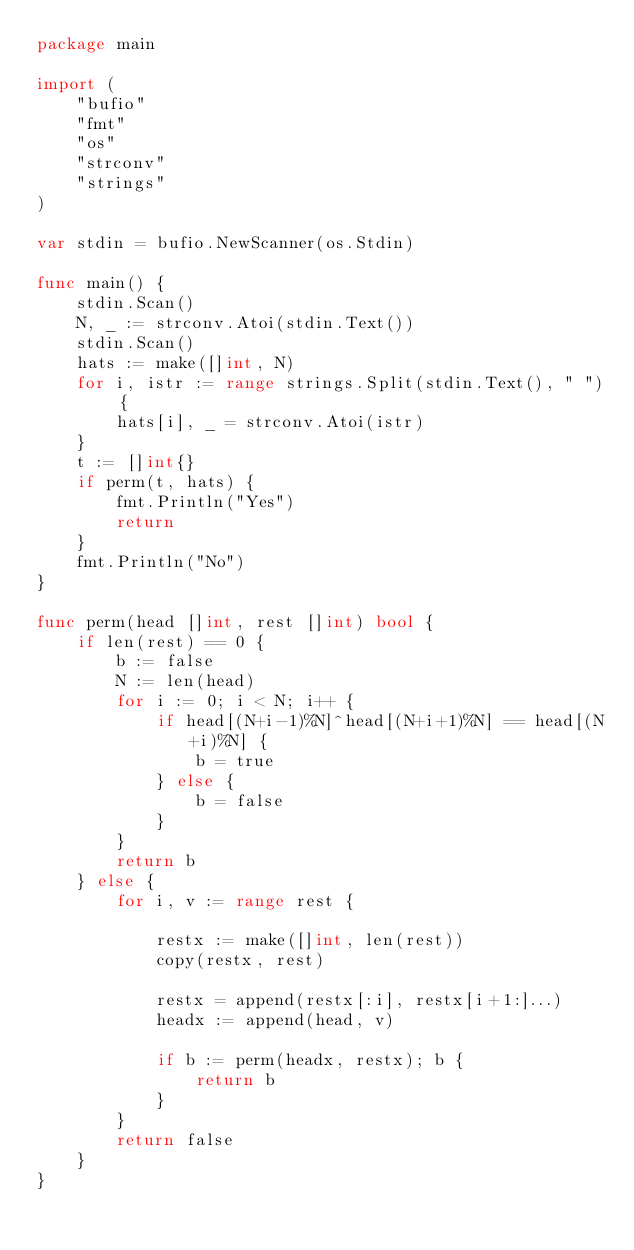Convert code to text. <code><loc_0><loc_0><loc_500><loc_500><_Go_>package main

import (
	"bufio"
	"fmt"
	"os"
	"strconv"
	"strings"
)

var stdin = bufio.NewScanner(os.Stdin)

func main() {
	stdin.Scan()
	N, _ := strconv.Atoi(stdin.Text())
	stdin.Scan()
	hats := make([]int, N)
	for i, istr := range strings.Split(stdin.Text(), " ") {
		hats[i], _ = strconv.Atoi(istr)
	}
	t := []int{}
	if perm(t, hats) {
		fmt.Println("Yes")
		return
	}
	fmt.Println("No")
}

func perm(head []int, rest []int) bool {
	if len(rest) == 0 {
		b := false
		N := len(head)
		for i := 0; i < N; i++ {
			if head[(N+i-1)%N]^head[(N+i+1)%N] == head[(N+i)%N] {
				b = true
			} else {
				b = false
			}
		}
		return b
	} else {
		for i, v := range rest {

			restx := make([]int, len(rest))
			copy(restx, rest)

			restx = append(restx[:i], restx[i+1:]...)
			headx := append(head, v)

			if b := perm(headx, restx); b {
				return b
			}
		}
		return false
	}
}</code> 